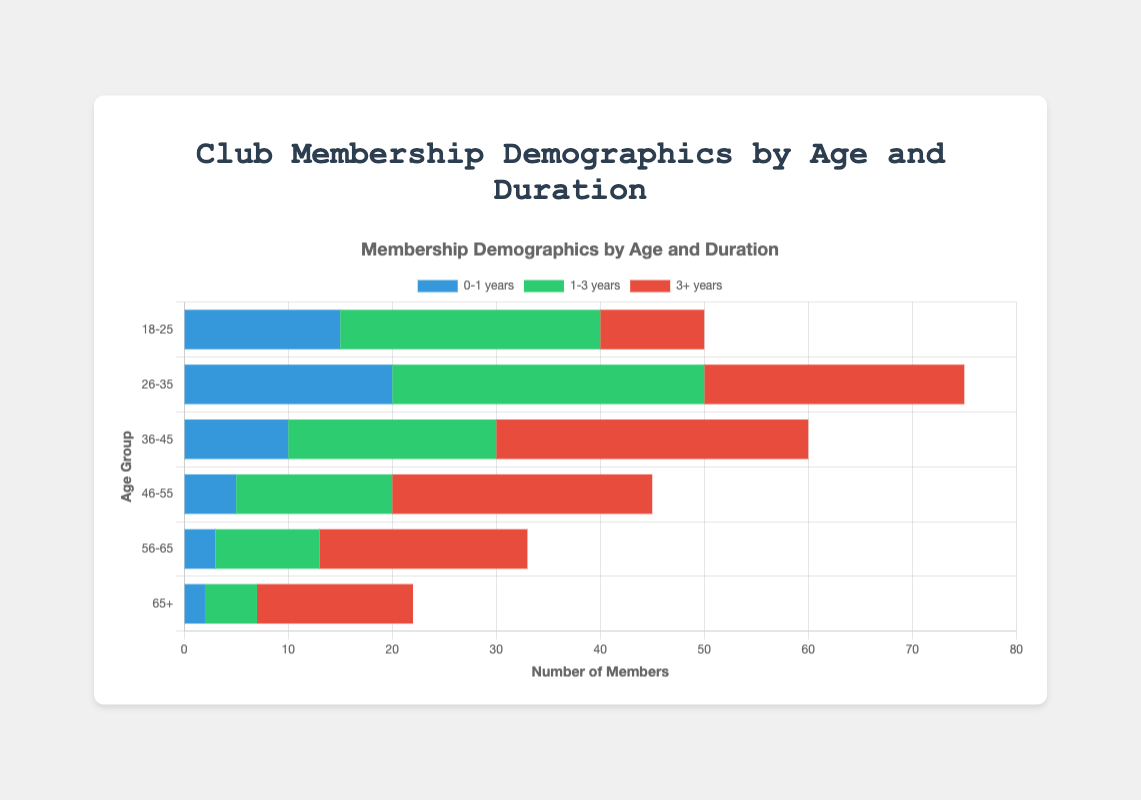What age group has the highest number of members with a 3+ years duration? The age group 36-45 has the highest number of members with a 3+ years duration, as indicated by the longest red bar in this category.
Answer: 36-45 Which age group has the least number of members with 0-1 years duration? The age group 65+ has the least number of members with 0-1 years duration, as indicated by the shortest blue bar in this category.
Answer: 65+ What is the total number of members in the 26-35 age group? Sum the members in the 26-35 age group across all durations: 20 (0-1 years) + 30 (1-3 years) + 25 (3+ years) = 75.
Answer: 75 Compare the number of members with a 1-3 years duration in the 18-25 and 46-55 age groups. Which group has more members? The 18-25 age group has 25 members with a 1-3 years duration, while the 46-55 age group has 15 members with a 1-3 years duration. Thus, the 18-25 age group has more members in this category.
Answer: 18-25 What age group has the highest combined number of members for 1-3 years and 3+ years durations? For each age group, sum the values of 1-3 years and 3+ years durations:
18-25: 25 + 10 = 35
26-35: 30 + 25 = 55
36-45: 20 + 30 = 50
46-55: 15 + 25 = 40
56-65: 10 + 20 = 30
65+: 5 + 15 = 20
The age group 26-35 has the highest combined number of members for 1-3 years and 3+ years durations.
Answer: 26-35 How does the number of members with a 1-3 years duration in the 36-45 age group compare to the 56-65 age group? The 36-45 age group has 20 members with a 1-3 years duration, and the 56-65 age group has 10 members with a 1-3 years duration. Therefore, the 36-45 age group has more members with a 1-3 years duration.
Answer: 36-45 In which age group is the proportion of long-term members (3+ years) the highest relative to the total members within that group? Calculate the proportion of 3+ years members for each age group:
18-25: 10/(15+25+10) = 10/50 = 0.2
26-35: 25/(20+30+25) = 25/75 = 0.33
36-45: 30/(10+20+30) = 30/60 = 0.5
46-55: 25/(5+15+25) = 25/45 = 0.56
56-65: 20/(3+10+20) = 20/33 = 0.61
65+: 15/(2+5+15) = 15/22 = 0.68
The 65+ age group has the highest proportion of long-term members.
Answer: 65+ Compare the total number of members aged 18-25 and aged 65+. Which group has more members? Sum the total number of members for each group:
18-25: 15 + 25 + 10 = 50
65+: 2 + 5 + 15 = 22
The 18-25 age group has more members.
Answer: 18-25 